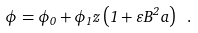Convert formula to latex. <formula><loc_0><loc_0><loc_500><loc_500>\phi = \phi _ { 0 } + \phi _ { 1 } z \left ( 1 + \varepsilon B ^ { 2 } a \right ) \ .</formula> 